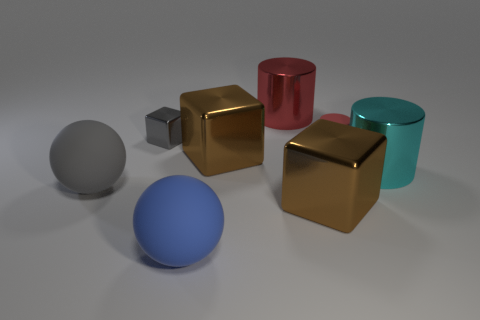There is another metallic object that is the same shape as the large cyan object; what color is it?
Offer a very short reply. Red. There is a thing that is in front of the cyan object and to the left of the large blue object; what size is it?
Provide a succinct answer. Large. What number of other things are the same size as the gray shiny cube?
Ensure brevity in your answer.  1. What color is the big cylinder in front of the thing behind the metal block left of the large blue rubber sphere?
Your answer should be very brief. Cyan. What shape is the thing that is behind the rubber cylinder and in front of the big red metallic cylinder?
Offer a terse response. Cube. What number of other objects are there of the same shape as the large gray rubber object?
Your answer should be compact. 1. What is the shape of the tiny thing to the right of the brown block that is right of the large shiny thing behind the small gray object?
Ensure brevity in your answer.  Cylinder. What number of things are big red shiny cylinders or tiny things that are behind the red matte cylinder?
Provide a succinct answer. 2. Does the cyan object to the right of the large gray matte object have the same shape as the matte thing that is on the right side of the blue rubber sphere?
Your answer should be compact. Yes. How many things are either blue spheres or small metal cubes?
Your response must be concise. 2. 